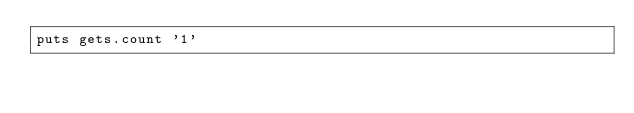<code> <loc_0><loc_0><loc_500><loc_500><_Ruby_>puts gets.count '1'</code> 